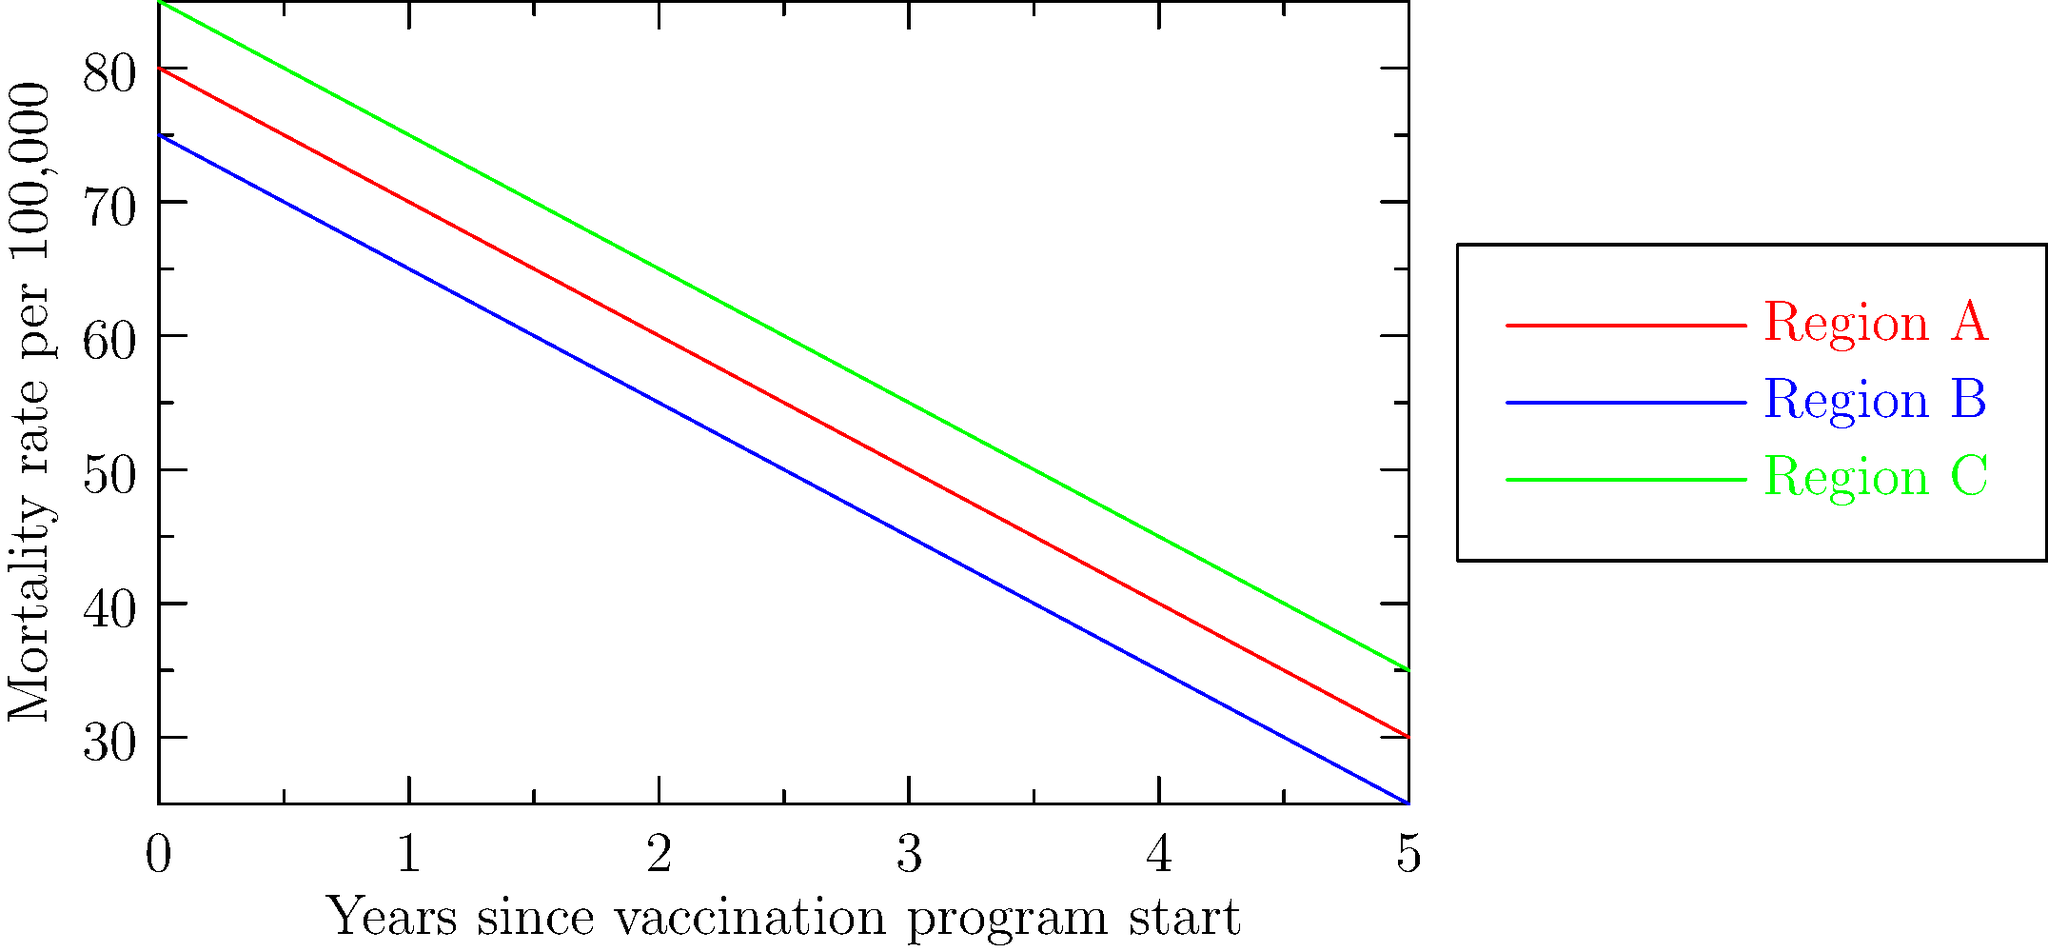Based on the line graph showing mortality rates for three regions over time since the start of their vaccination programs, which region shows the most significant reduction in mortality rate, and what does this suggest about the effectiveness of their vaccination strategy? To determine which region shows the most significant reduction in mortality rate, we need to analyze the slope of each line:

1. Calculate the total change in mortality rate for each region:
   Region A: 80 - 30 = 50
   Region B: 75 - 25 = 50
   Region C: 85 - 35 = 50

2. Observe that all regions have the same total change, so we need to look at the rate of change.

3. Calculate the rate of change (slope) for each region:
   Rate of change = Total change / Time period
   For all regions: 50 / 5 years = 10 per year

4. Since all regions have the same rate of change, we need to consider the relative change:
   Relative change = (Initial value - Final value) / Initial value * 100%
   Region A: (80 - 30) / 80 * 100% = 62.5%
   Region B: (75 - 25) / 75 * 100% = 66.7%
   Region C: (85 - 35) / 85 * 100% = 58.8%

5. Region B has the highest relative change, indicating the most significant reduction in mortality rate.

This suggests that Region B's vaccination strategy may be the most effective, as it achieved the greatest proportional decrease in mortality rate over the given time period. Factors contributing to this could include higher vaccination coverage, better targeted vaccination programs, or more effective healthcare infrastructure to support the vaccination efforts.
Answer: Region B; highest relative mortality rate reduction (66.7%) suggests most effective vaccination strategy. 